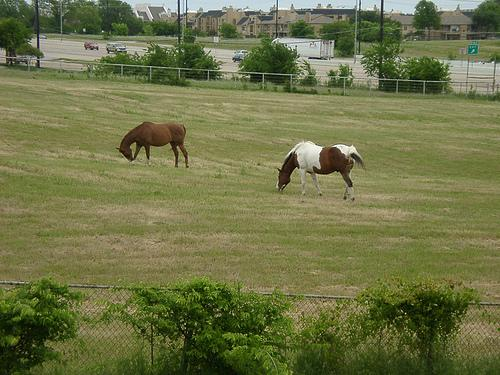Question: where is the highway?
Choices:
A. Across the street.
B. Next to the convenience store.
C. Next to the meadow.
D. Across from the lake.
Answer with the letter. Answer: C Question: what color are the townhouses?
Choices:
A. Red.
B. Green.
C. Tan.
D. Blue.
Answer with the letter. Answer: C Question: what are the animals doing?
Choices:
A. Eating grass.
B. Playing.
C. Chasing each other.
D. Running.
Answer with the letter. Answer: A 